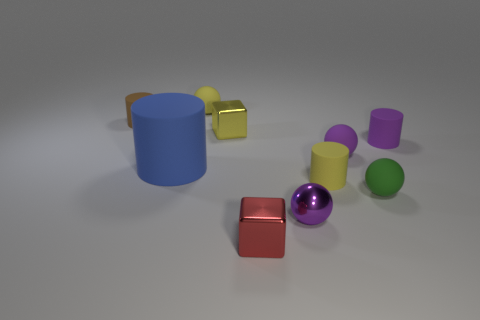Subtract all yellow spheres. How many spheres are left? 3 Subtract all red cylinders. Subtract all yellow balls. How many cylinders are left? 4 Subtract all blocks. How many objects are left? 8 Subtract all small blue metal things. Subtract all tiny things. How many objects are left? 1 Add 1 blue cylinders. How many blue cylinders are left? 2 Add 1 red shiny cylinders. How many red shiny cylinders exist? 1 Subtract 1 brown cylinders. How many objects are left? 9 